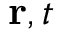Convert formula to latex. <formula><loc_0><loc_0><loc_500><loc_500>{ r } , t</formula> 